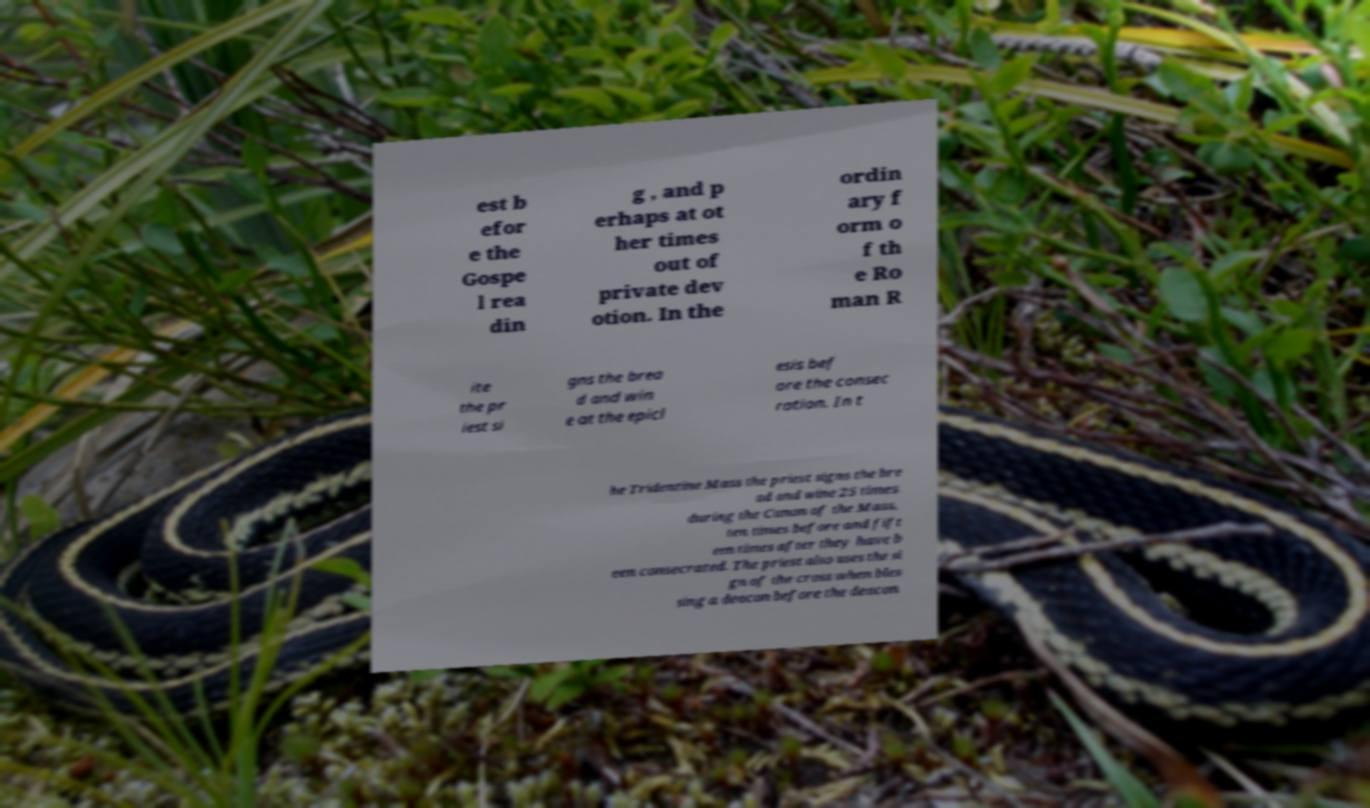There's text embedded in this image that I need extracted. Can you transcribe it verbatim? est b efor e the Gospe l rea din g , and p erhaps at ot her times out of private dev otion. In the ordin ary f orm o f th e Ro man R ite the pr iest si gns the brea d and win e at the epicl esis bef ore the consec ration. In t he Tridentine Mass the priest signs the bre ad and wine 25 times during the Canon of the Mass, ten times before and fift een times after they have b een consecrated. The priest also uses the si gn of the cross when bles sing a deacon before the deacon 